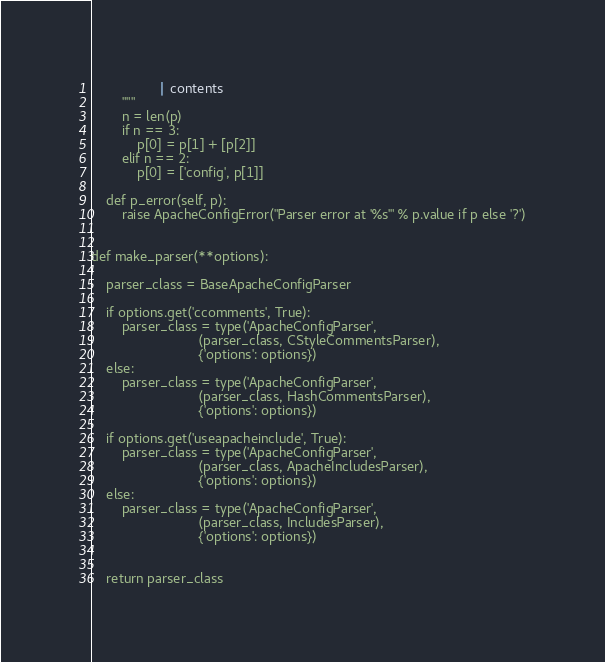Convert code to text. <code><loc_0><loc_0><loc_500><loc_500><_Python_>                  | contents
        """
        n = len(p)
        if n == 3:
            p[0] = p[1] + [p[2]]
        elif n == 2:
            p[0] = ['config', p[1]]

    def p_error(self, p):
        raise ApacheConfigError("Parser error at '%s'" % p.value if p else '?')


def make_parser(**options):

    parser_class = BaseApacheConfigParser

    if options.get('ccomments', True):
        parser_class = type('ApacheConfigParser',
                            (parser_class, CStyleCommentsParser),
                            {'options': options})
    else:
        parser_class = type('ApacheConfigParser',
                            (parser_class, HashCommentsParser),
                            {'options': options})

    if options.get('useapacheinclude', True):
        parser_class = type('ApacheConfigParser',
                            (parser_class, ApacheIncludesParser),
                            {'options': options})
    else:
        parser_class = type('ApacheConfigParser',
                            (parser_class, IncludesParser),
                            {'options': options})


    return parser_class
</code> 